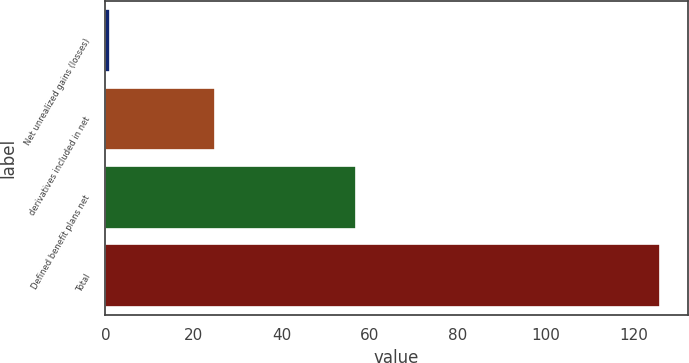<chart> <loc_0><loc_0><loc_500><loc_500><bar_chart><fcel>Net unrealized gains (losses)<fcel>derivatives included in net<fcel>Defined benefit plans net<fcel>Total<nl><fcel>1<fcel>25<fcel>57<fcel>126<nl></chart> 